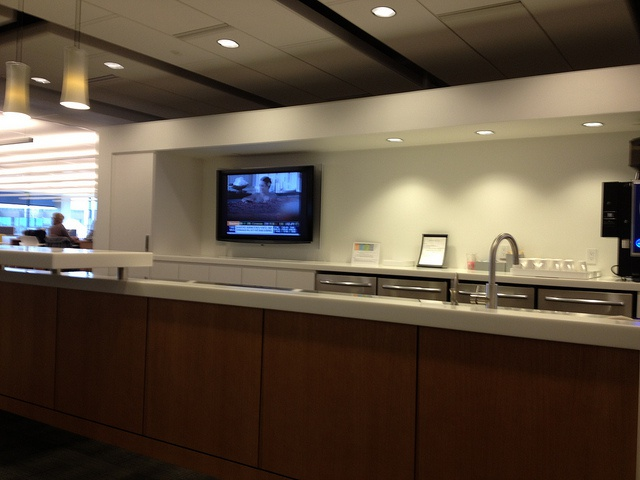Describe the objects in this image and their specific colors. I can see tv in gray, black, navy, lightblue, and blue tones, people in gray, maroon, and black tones, cup in gray, tan, and lightyellow tones, cup in gray and tan tones, and cup in gray, tan, and lightyellow tones in this image. 